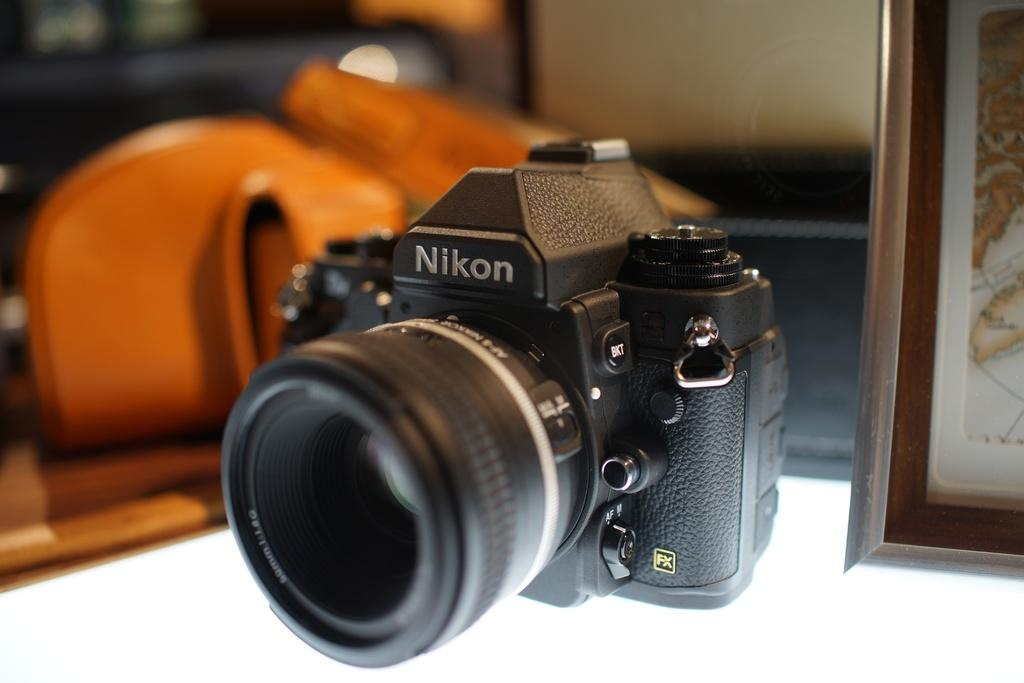What is the main object in the image? There is a camera in the image. What can be seen on the right side of the image? There is a photo frame on the right side of the image. What is present on the left side of the image? There are objects on the left side of the image. Can you tell me how many toads are sitting on the camera in the image? There are no toads present in the image; it features a camera and a photo frame. What type of legal advice is the lawyer providing in the image? There is no lawyer present in the image; it features a camera and a photo frame. 